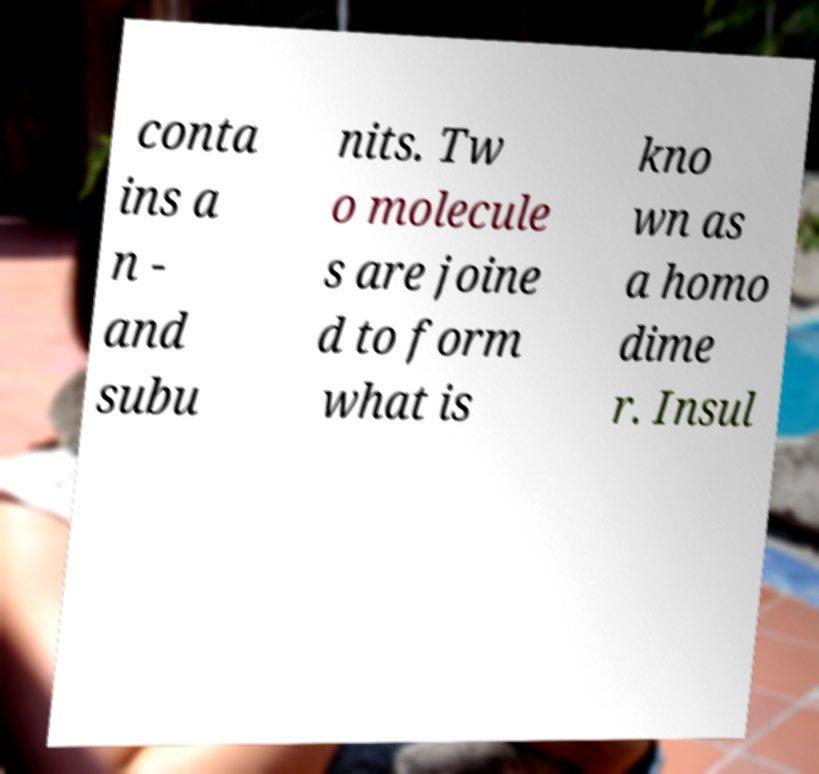For documentation purposes, I need the text within this image transcribed. Could you provide that? conta ins a n - and subu nits. Tw o molecule s are joine d to form what is kno wn as a homo dime r. Insul 